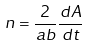Convert formula to latex. <formula><loc_0><loc_0><loc_500><loc_500>n = \frac { 2 } { a b } \frac { d A } { d t }</formula> 